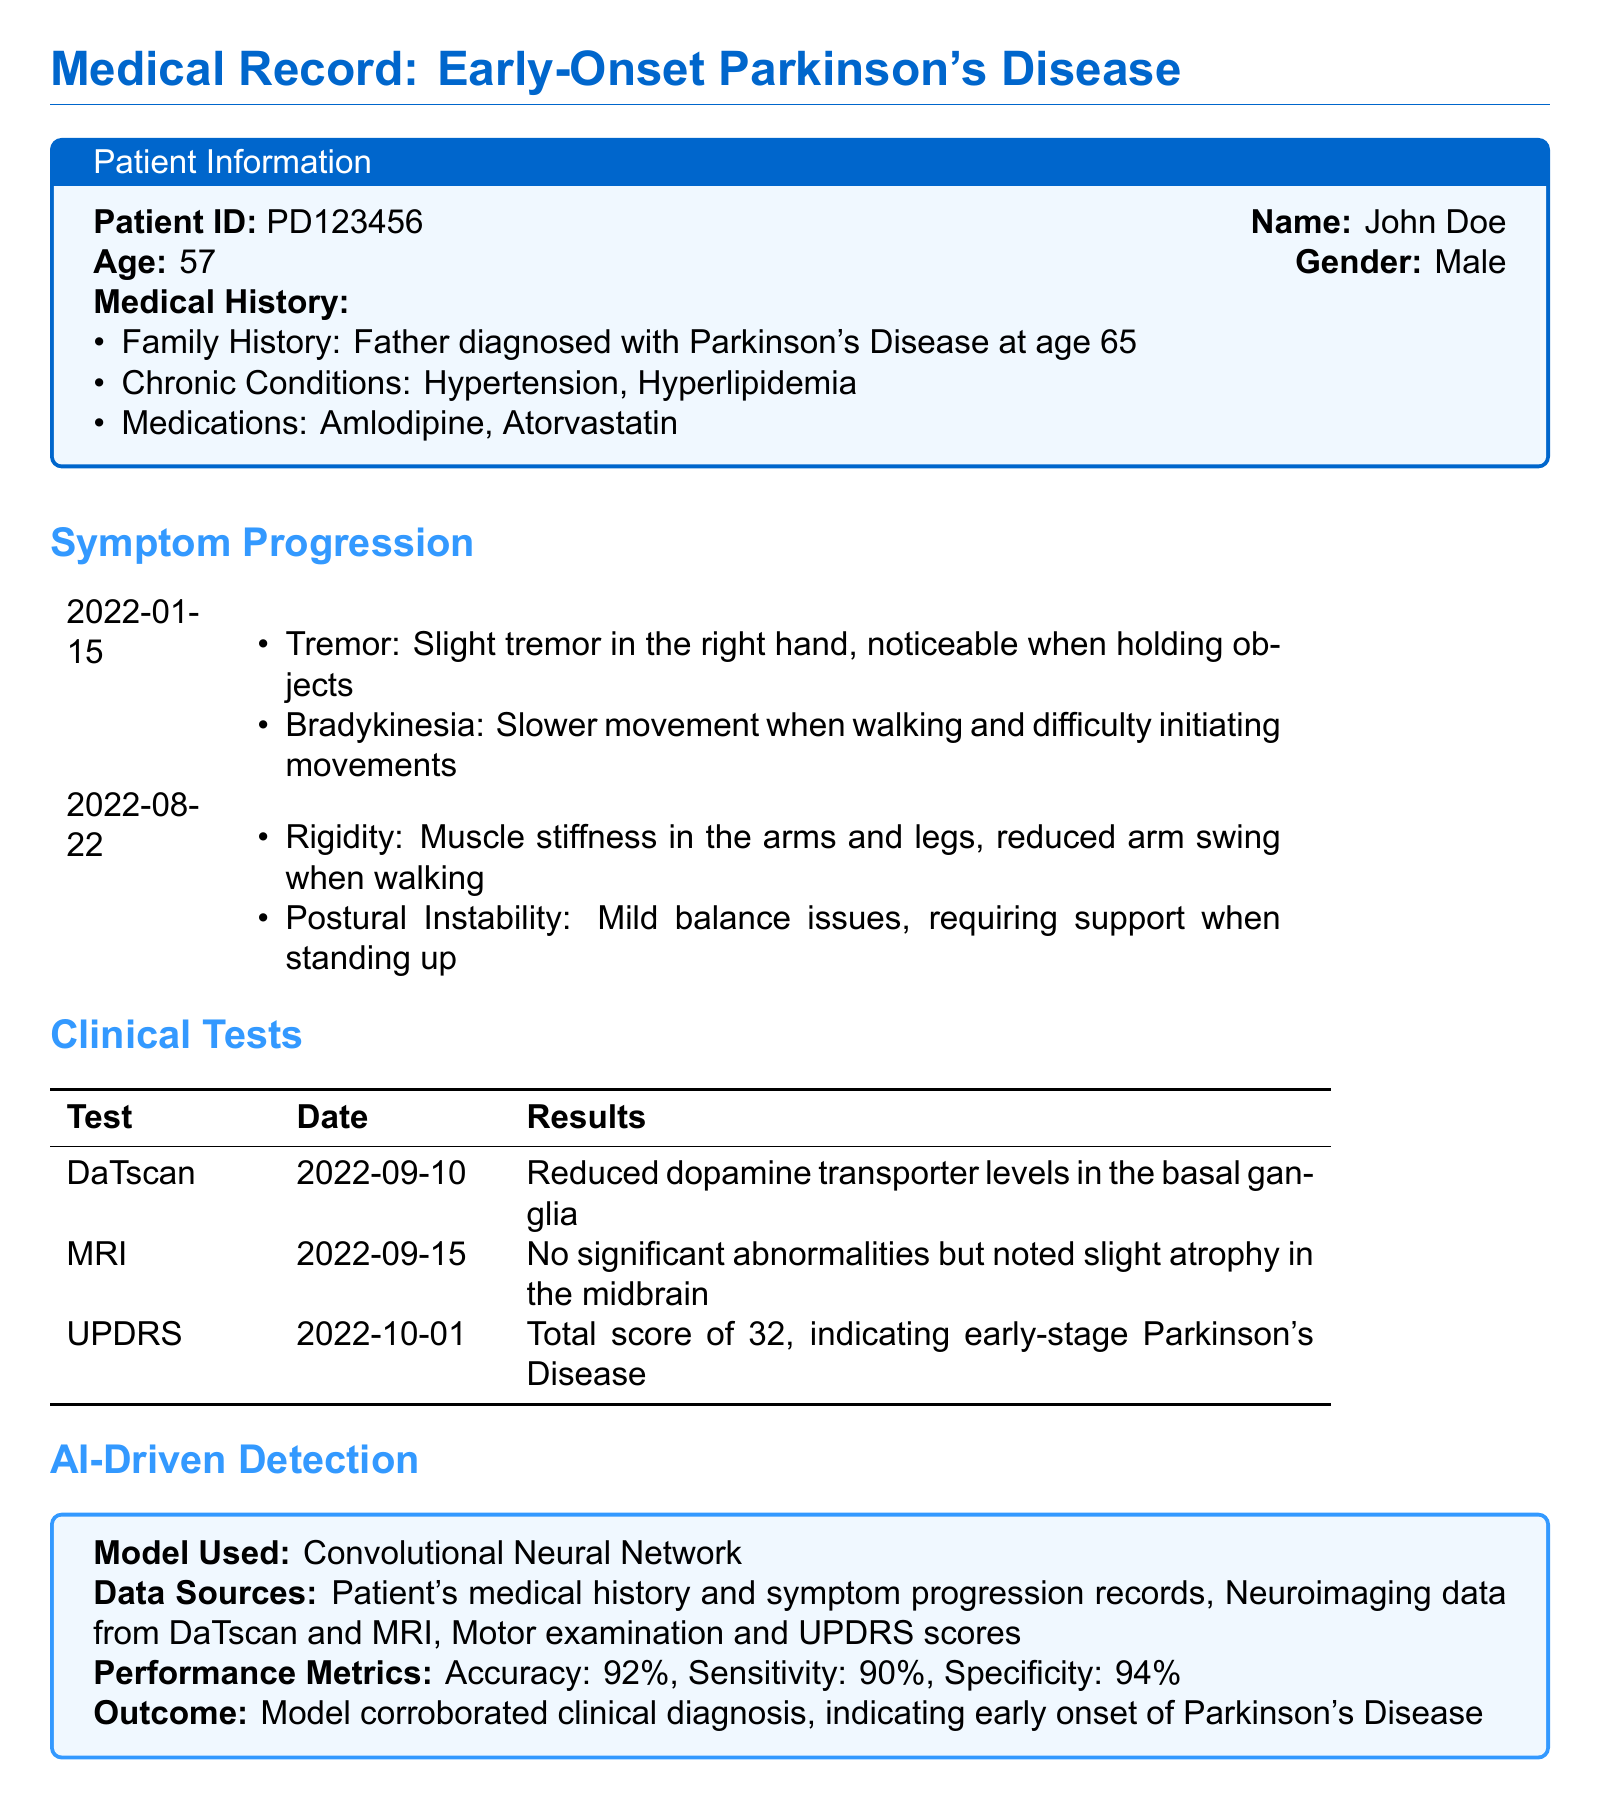What is the patient ID? The patient ID is provided in the patient information section of the document.
Answer: PD123456 What medications is the patient taking? The list of medications is outlined in the patient information section.
Answer: Amlodipine, Atorvastatin What was the total UPDRS score recorded? The UPDRS score is specified in the clinical tests section, indicating the severity of the condition.
Answer: 32 What type of model was used for AI-driven detection? This information is found in the AI-driven detection segment of the document.
Answer: Convolutional Neural Network What is the recommended treatment for the patient? The summary section details the recommended treatment regimen for the patient.
Answer: Levodopa, 50 mg, three times a day; Physical Therapy, twice a week What date did the MRI take place? The date of the MRI is listed in the clinical tests table.
Answer: 2022-09-15 What was the accuracy of the AI model? This performance metric is mentioned in the AI-driven detection section.
Answer: 92% What symptom was reported on 2022-01-15? Symptoms reported on specific dates are outlined in the symptom progression section.
Answer: Slight tremor in the right hand 